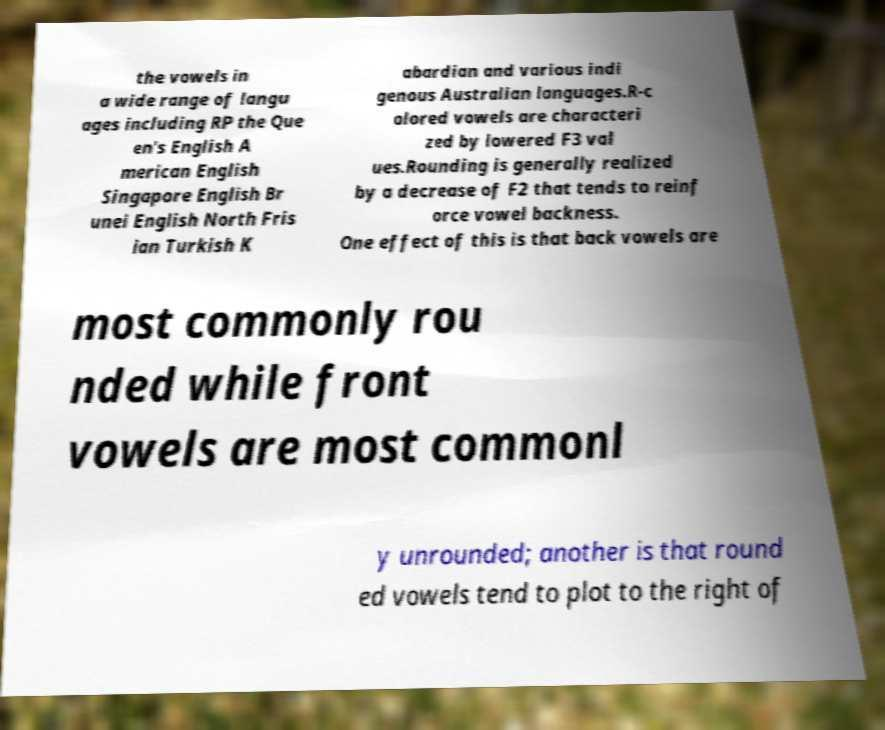Can you accurately transcribe the text from the provided image for me? the vowels in a wide range of langu ages including RP the Que en's English A merican English Singapore English Br unei English North Fris ian Turkish K abardian and various indi genous Australian languages.R-c olored vowels are characteri zed by lowered F3 val ues.Rounding is generally realized by a decrease of F2 that tends to reinf orce vowel backness. One effect of this is that back vowels are most commonly rou nded while front vowels are most commonl y unrounded; another is that round ed vowels tend to plot to the right of 